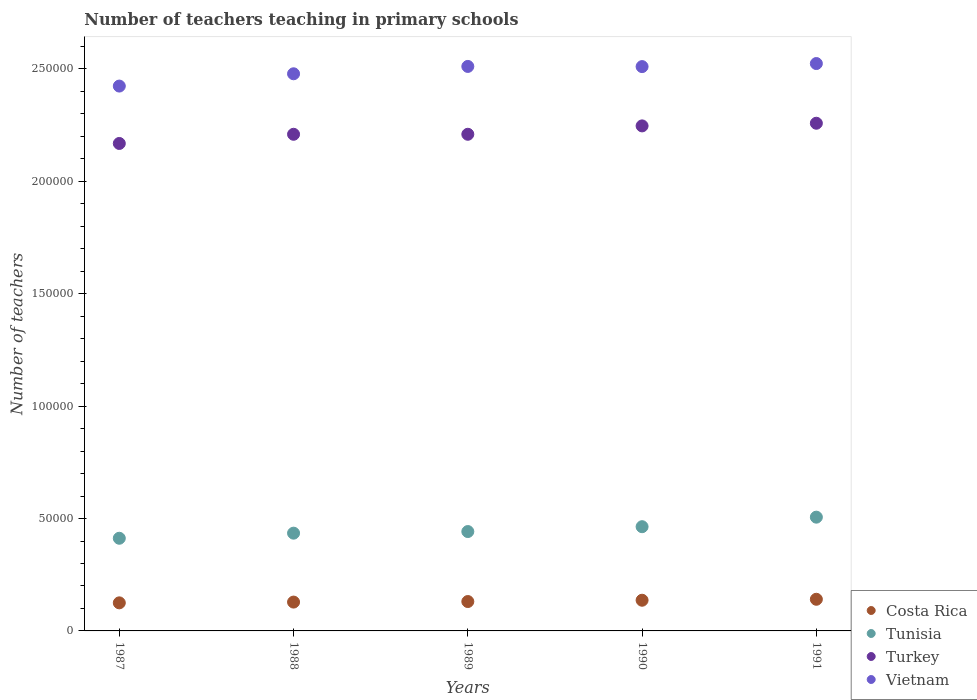How many different coloured dotlines are there?
Offer a very short reply. 4. Is the number of dotlines equal to the number of legend labels?
Your answer should be compact. Yes. What is the number of teachers teaching in primary schools in Costa Rica in 1991?
Provide a succinct answer. 1.41e+04. Across all years, what is the maximum number of teachers teaching in primary schools in Costa Rica?
Offer a terse response. 1.41e+04. Across all years, what is the minimum number of teachers teaching in primary schools in Vietnam?
Provide a succinct answer. 2.42e+05. In which year was the number of teachers teaching in primary schools in Tunisia maximum?
Your answer should be compact. 1991. What is the total number of teachers teaching in primary schools in Tunisia in the graph?
Your response must be concise. 2.26e+05. What is the difference between the number of teachers teaching in primary schools in Tunisia in 1987 and that in 1989?
Your answer should be compact. -2985. What is the difference between the number of teachers teaching in primary schools in Tunisia in 1989 and the number of teachers teaching in primary schools in Costa Rica in 1987?
Keep it short and to the point. 3.17e+04. What is the average number of teachers teaching in primary schools in Tunisia per year?
Offer a terse response. 4.52e+04. In the year 1990, what is the difference between the number of teachers teaching in primary schools in Vietnam and number of teachers teaching in primary schools in Tunisia?
Ensure brevity in your answer.  2.05e+05. What is the ratio of the number of teachers teaching in primary schools in Vietnam in 1990 to that in 1991?
Your answer should be compact. 0.99. Is the number of teachers teaching in primary schools in Turkey in 1987 less than that in 1989?
Keep it short and to the point. Yes. Is the difference between the number of teachers teaching in primary schools in Vietnam in 1988 and 1991 greater than the difference between the number of teachers teaching in primary schools in Tunisia in 1988 and 1991?
Keep it short and to the point. Yes. What is the difference between the highest and the second highest number of teachers teaching in primary schools in Vietnam?
Your response must be concise. 1286. What is the difference between the highest and the lowest number of teachers teaching in primary schools in Vietnam?
Provide a short and direct response. 1.00e+04. In how many years, is the number of teachers teaching in primary schools in Costa Rica greater than the average number of teachers teaching in primary schools in Costa Rica taken over all years?
Give a very brief answer. 2. Does the number of teachers teaching in primary schools in Vietnam monotonically increase over the years?
Provide a succinct answer. No. Is the number of teachers teaching in primary schools in Vietnam strictly greater than the number of teachers teaching in primary schools in Tunisia over the years?
Ensure brevity in your answer.  Yes. Is the number of teachers teaching in primary schools in Costa Rica strictly less than the number of teachers teaching in primary schools in Vietnam over the years?
Your answer should be very brief. Yes. How many years are there in the graph?
Give a very brief answer. 5. What is the difference between two consecutive major ticks on the Y-axis?
Give a very brief answer. 5.00e+04. Are the values on the major ticks of Y-axis written in scientific E-notation?
Keep it short and to the point. No. Does the graph contain any zero values?
Offer a very short reply. No. Does the graph contain grids?
Provide a succinct answer. No. How many legend labels are there?
Your answer should be compact. 4. What is the title of the graph?
Your response must be concise. Number of teachers teaching in primary schools. What is the label or title of the Y-axis?
Keep it short and to the point. Number of teachers. What is the Number of teachers of Costa Rica in 1987?
Offer a terse response. 1.25e+04. What is the Number of teachers of Tunisia in 1987?
Your answer should be compact. 4.12e+04. What is the Number of teachers of Turkey in 1987?
Offer a very short reply. 2.17e+05. What is the Number of teachers of Vietnam in 1987?
Your answer should be very brief. 2.42e+05. What is the Number of teachers in Costa Rica in 1988?
Give a very brief answer. 1.28e+04. What is the Number of teachers in Tunisia in 1988?
Make the answer very short. 4.35e+04. What is the Number of teachers in Turkey in 1988?
Offer a very short reply. 2.21e+05. What is the Number of teachers in Vietnam in 1988?
Ensure brevity in your answer.  2.48e+05. What is the Number of teachers of Costa Rica in 1989?
Provide a succinct answer. 1.31e+04. What is the Number of teachers of Tunisia in 1989?
Your response must be concise. 4.42e+04. What is the Number of teachers in Turkey in 1989?
Offer a very short reply. 2.21e+05. What is the Number of teachers in Vietnam in 1989?
Your answer should be compact. 2.51e+05. What is the Number of teachers of Costa Rica in 1990?
Keep it short and to the point. 1.37e+04. What is the Number of teachers in Tunisia in 1990?
Make the answer very short. 4.64e+04. What is the Number of teachers in Turkey in 1990?
Your response must be concise. 2.25e+05. What is the Number of teachers of Vietnam in 1990?
Your answer should be very brief. 2.51e+05. What is the Number of teachers of Costa Rica in 1991?
Provide a succinct answer. 1.41e+04. What is the Number of teachers in Tunisia in 1991?
Your answer should be compact. 5.06e+04. What is the Number of teachers in Turkey in 1991?
Your answer should be very brief. 2.26e+05. What is the Number of teachers in Vietnam in 1991?
Make the answer very short. 2.52e+05. Across all years, what is the maximum Number of teachers of Costa Rica?
Ensure brevity in your answer.  1.41e+04. Across all years, what is the maximum Number of teachers of Tunisia?
Offer a very short reply. 5.06e+04. Across all years, what is the maximum Number of teachers in Turkey?
Your answer should be very brief. 2.26e+05. Across all years, what is the maximum Number of teachers of Vietnam?
Ensure brevity in your answer.  2.52e+05. Across all years, what is the minimum Number of teachers in Costa Rica?
Offer a terse response. 1.25e+04. Across all years, what is the minimum Number of teachers in Tunisia?
Make the answer very short. 4.12e+04. Across all years, what is the minimum Number of teachers in Turkey?
Your answer should be compact. 2.17e+05. Across all years, what is the minimum Number of teachers of Vietnam?
Ensure brevity in your answer.  2.42e+05. What is the total Number of teachers of Costa Rica in the graph?
Provide a succinct answer. 6.61e+04. What is the total Number of teachers of Tunisia in the graph?
Make the answer very short. 2.26e+05. What is the total Number of teachers of Turkey in the graph?
Your answer should be very brief. 1.11e+06. What is the total Number of teachers of Vietnam in the graph?
Keep it short and to the point. 1.24e+06. What is the difference between the Number of teachers in Costa Rica in 1987 and that in 1988?
Ensure brevity in your answer.  -339. What is the difference between the Number of teachers in Tunisia in 1987 and that in 1988?
Provide a short and direct response. -2267. What is the difference between the Number of teachers of Turkey in 1987 and that in 1988?
Offer a very short reply. -4084. What is the difference between the Number of teachers in Vietnam in 1987 and that in 1988?
Your answer should be compact. -5468. What is the difference between the Number of teachers of Costa Rica in 1987 and that in 1989?
Make the answer very short. -583. What is the difference between the Number of teachers of Tunisia in 1987 and that in 1989?
Make the answer very short. -2985. What is the difference between the Number of teachers in Turkey in 1987 and that in 1989?
Give a very brief answer. -4088. What is the difference between the Number of teachers in Vietnam in 1987 and that in 1989?
Provide a succinct answer. -8739. What is the difference between the Number of teachers of Costa Rica in 1987 and that in 1990?
Your answer should be very brief. -1161. What is the difference between the Number of teachers of Tunisia in 1987 and that in 1990?
Provide a succinct answer. -5143. What is the difference between the Number of teachers in Turkey in 1987 and that in 1990?
Offer a terse response. -7813. What is the difference between the Number of teachers in Vietnam in 1987 and that in 1990?
Offer a very short reply. -8664. What is the difference between the Number of teachers in Costa Rica in 1987 and that in 1991?
Offer a terse response. -1588. What is the difference between the Number of teachers of Tunisia in 1987 and that in 1991?
Offer a very short reply. -9386. What is the difference between the Number of teachers in Turkey in 1987 and that in 1991?
Provide a short and direct response. -8993. What is the difference between the Number of teachers of Vietnam in 1987 and that in 1991?
Give a very brief answer. -1.00e+04. What is the difference between the Number of teachers of Costa Rica in 1988 and that in 1989?
Your response must be concise. -244. What is the difference between the Number of teachers of Tunisia in 1988 and that in 1989?
Your response must be concise. -718. What is the difference between the Number of teachers in Vietnam in 1988 and that in 1989?
Offer a terse response. -3271. What is the difference between the Number of teachers in Costa Rica in 1988 and that in 1990?
Provide a short and direct response. -822. What is the difference between the Number of teachers of Tunisia in 1988 and that in 1990?
Offer a very short reply. -2876. What is the difference between the Number of teachers in Turkey in 1988 and that in 1990?
Your answer should be very brief. -3729. What is the difference between the Number of teachers in Vietnam in 1988 and that in 1990?
Your answer should be very brief. -3196. What is the difference between the Number of teachers in Costa Rica in 1988 and that in 1991?
Provide a succinct answer. -1249. What is the difference between the Number of teachers of Tunisia in 1988 and that in 1991?
Provide a short and direct response. -7119. What is the difference between the Number of teachers of Turkey in 1988 and that in 1991?
Make the answer very short. -4909. What is the difference between the Number of teachers in Vietnam in 1988 and that in 1991?
Provide a succinct answer. -4557. What is the difference between the Number of teachers in Costa Rica in 1989 and that in 1990?
Your answer should be compact. -578. What is the difference between the Number of teachers of Tunisia in 1989 and that in 1990?
Give a very brief answer. -2158. What is the difference between the Number of teachers of Turkey in 1989 and that in 1990?
Give a very brief answer. -3725. What is the difference between the Number of teachers of Vietnam in 1989 and that in 1990?
Make the answer very short. 75. What is the difference between the Number of teachers of Costa Rica in 1989 and that in 1991?
Offer a very short reply. -1005. What is the difference between the Number of teachers in Tunisia in 1989 and that in 1991?
Ensure brevity in your answer.  -6401. What is the difference between the Number of teachers of Turkey in 1989 and that in 1991?
Provide a succinct answer. -4905. What is the difference between the Number of teachers in Vietnam in 1989 and that in 1991?
Give a very brief answer. -1286. What is the difference between the Number of teachers of Costa Rica in 1990 and that in 1991?
Your response must be concise. -427. What is the difference between the Number of teachers of Tunisia in 1990 and that in 1991?
Offer a terse response. -4243. What is the difference between the Number of teachers of Turkey in 1990 and that in 1991?
Your answer should be very brief. -1180. What is the difference between the Number of teachers in Vietnam in 1990 and that in 1991?
Your answer should be compact. -1361. What is the difference between the Number of teachers of Costa Rica in 1987 and the Number of teachers of Tunisia in 1988?
Provide a short and direct response. -3.10e+04. What is the difference between the Number of teachers of Costa Rica in 1987 and the Number of teachers of Turkey in 1988?
Provide a succinct answer. -2.08e+05. What is the difference between the Number of teachers in Costa Rica in 1987 and the Number of teachers in Vietnam in 1988?
Your response must be concise. -2.35e+05. What is the difference between the Number of teachers of Tunisia in 1987 and the Number of teachers of Turkey in 1988?
Provide a succinct answer. -1.80e+05. What is the difference between the Number of teachers in Tunisia in 1987 and the Number of teachers in Vietnam in 1988?
Provide a succinct answer. -2.07e+05. What is the difference between the Number of teachers of Turkey in 1987 and the Number of teachers of Vietnam in 1988?
Offer a terse response. -3.10e+04. What is the difference between the Number of teachers of Costa Rica in 1987 and the Number of teachers of Tunisia in 1989?
Give a very brief answer. -3.17e+04. What is the difference between the Number of teachers in Costa Rica in 1987 and the Number of teachers in Turkey in 1989?
Offer a very short reply. -2.08e+05. What is the difference between the Number of teachers in Costa Rica in 1987 and the Number of teachers in Vietnam in 1989?
Keep it short and to the point. -2.39e+05. What is the difference between the Number of teachers in Tunisia in 1987 and the Number of teachers in Turkey in 1989?
Give a very brief answer. -1.80e+05. What is the difference between the Number of teachers in Tunisia in 1987 and the Number of teachers in Vietnam in 1989?
Provide a short and direct response. -2.10e+05. What is the difference between the Number of teachers in Turkey in 1987 and the Number of teachers in Vietnam in 1989?
Offer a very short reply. -3.43e+04. What is the difference between the Number of teachers in Costa Rica in 1987 and the Number of teachers in Tunisia in 1990?
Keep it short and to the point. -3.39e+04. What is the difference between the Number of teachers in Costa Rica in 1987 and the Number of teachers in Turkey in 1990?
Offer a terse response. -2.12e+05. What is the difference between the Number of teachers of Costa Rica in 1987 and the Number of teachers of Vietnam in 1990?
Ensure brevity in your answer.  -2.39e+05. What is the difference between the Number of teachers of Tunisia in 1987 and the Number of teachers of Turkey in 1990?
Your answer should be compact. -1.83e+05. What is the difference between the Number of teachers of Tunisia in 1987 and the Number of teachers of Vietnam in 1990?
Provide a short and direct response. -2.10e+05. What is the difference between the Number of teachers of Turkey in 1987 and the Number of teachers of Vietnam in 1990?
Ensure brevity in your answer.  -3.42e+04. What is the difference between the Number of teachers in Costa Rica in 1987 and the Number of teachers in Tunisia in 1991?
Offer a terse response. -3.81e+04. What is the difference between the Number of teachers of Costa Rica in 1987 and the Number of teachers of Turkey in 1991?
Offer a very short reply. -2.13e+05. What is the difference between the Number of teachers in Costa Rica in 1987 and the Number of teachers in Vietnam in 1991?
Ensure brevity in your answer.  -2.40e+05. What is the difference between the Number of teachers of Tunisia in 1987 and the Number of teachers of Turkey in 1991?
Provide a succinct answer. -1.85e+05. What is the difference between the Number of teachers of Tunisia in 1987 and the Number of teachers of Vietnam in 1991?
Offer a terse response. -2.11e+05. What is the difference between the Number of teachers in Turkey in 1987 and the Number of teachers in Vietnam in 1991?
Provide a succinct answer. -3.56e+04. What is the difference between the Number of teachers in Costa Rica in 1988 and the Number of teachers in Tunisia in 1989?
Your response must be concise. -3.14e+04. What is the difference between the Number of teachers of Costa Rica in 1988 and the Number of teachers of Turkey in 1989?
Ensure brevity in your answer.  -2.08e+05. What is the difference between the Number of teachers of Costa Rica in 1988 and the Number of teachers of Vietnam in 1989?
Your answer should be compact. -2.38e+05. What is the difference between the Number of teachers of Tunisia in 1988 and the Number of teachers of Turkey in 1989?
Offer a terse response. -1.77e+05. What is the difference between the Number of teachers in Tunisia in 1988 and the Number of teachers in Vietnam in 1989?
Your answer should be very brief. -2.08e+05. What is the difference between the Number of teachers of Turkey in 1988 and the Number of teachers of Vietnam in 1989?
Provide a short and direct response. -3.02e+04. What is the difference between the Number of teachers of Costa Rica in 1988 and the Number of teachers of Tunisia in 1990?
Offer a very short reply. -3.35e+04. What is the difference between the Number of teachers in Costa Rica in 1988 and the Number of teachers in Turkey in 1990?
Provide a succinct answer. -2.12e+05. What is the difference between the Number of teachers of Costa Rica in 1988 and the Number of teachers of Vietnam in 1990?
Ensure brevity in your answer.  -2.38e+05. What is the difference between the Number of teachers of Tunisia in 1988 and the Number of teachers of Turkey in 1990?
Your answer should be compact. -1.81e+05. What is the difference between the Number of teachers of Tunisia in 1988 and the Number of teachers of Vietnam in 1990?
Provide a short and direct response. -2.08e+05. What is the difference between the Number of teachers in Turkey in 1988 and the Number of teachers in Vietnam in 1990?
Give a very brief answer. -3.01e+04. What is the difference between the Number of teachers of Costa Rica in 1988 and the Number of teachers of Tunisia in 1991?
Provide a succinct answer. -3.78e+04. What is the difference between the Number of teachers of Costa Rica in 1988 and the Number of teachers of Turkey in 1991?
Give a very brief answer. -2.13e+05. What is the difference between the Number of teachers in Costa Rica in 1988 and the Number of teachers in Vietnam in 1991?
Offer a terse response. -2.40e+05. What is the difference between the Number of teachers of Tunisia in 1988 and the Number of teachers of Turkey in 1991?
Provide a succinct answer. -1.82e+05. What is the difference between the Number of teachers of Tunisia in 1988 and the Number of teachers of Vietnam in 1991?
Offer a very short reply. -2.09e+05. What is the difference between the Number of teachers in Turkey in 1988 and the Number of teachers in Vietnam in 1991?
Make the answer very short. -3.15e+04. What is the difference between the Number of teachers of Costa Rica in 1989 and the Number of teachers of Tunisia in 1990?
Keep it short and to the point. -3.33e+04. What is the difference between the Number of teachers in Costa Rica in 1989 and the Number of teachers in Turkey in 1990?
Provide a succinct answer. -2.12e+05. What is the difference between the Number of teachers of Costa Rica in 1989 and the Number of teachers of Vietnam in 1990?
Offer a terse response. -2.38e+05. What is the difference between the Number of teachers in Tunisia in 1989 and the Number of teachers in Turkey in 1990?
Your answer should be very brief. -1.80e+05. What is the difference between the Number of teachers in Tunisia in 1989 and the Number of teachers in Vietnam in 1990?
Offer a terse response. -2.07e+05. What is the difference between the Number of teachers in Turkey in 1989 and the Number of teachers in Vietnam in 1990?
Keep it short and to the point. -3.01e+04. What is the difference between the Number of teachers of Costa Rica in 1989 and the Number of teachers of Tunisia in 1991?
Give a very brief answer. -3.75e+04. What is the difference between the Number of teachers in Costa Rica in 1989 and the Number of teachers in Turkey in 1991?
Keep it short and to the point. -2.13e+05. What is the difference between the Number of teachers of Costa Rica in 1989 and the Number of teachers of Vietnam in 1991?
Offer a very short reply. -2.39e+05. What is the difference between the Number of teachers in Tunisia in 1989 and the Number of teachers in Turkey in 1991?
Your response must be concise. -1.82e+05. What is the difference between the Number of teachers of Tunisia in 1989 and the Number of teachers of Vietnam in 1991?
Your answer should be very brief. -2.08e+05. What is the difference between the Number of teachers of Turkey in 1989 and the Number of teachers of Vietnam in 1991?
Your answer should be very brief. -3.15e+04. What is the difference between the Number of teachers of Costa Rica in 1990 and the Number of teachers of Tunisia in 1991?
Your response must be concise. -3.70e+04. What is the difference between the Number of teachers of Costa Rica in 1990 and the Number of teachers of Turkey in 1991?
Provide a succinct answer. -2.12e+05. What is the difference between the Number of teachers of Costa Rica in 1990 and the Number of teachers of Vietnam in 1991?
Offer a very short reply. -2.39e+05. What is the difference between the Number of teachers in Tunisia in 1990 and the Number of teachers in Turkey in 1991?
Give a very brief answer. -1.79e+05. What is the difference between the Number of teachers of Tunisia in 1990 and the Number of teachers of Vietnam in 1991?
Offer a very short reply. -2.06e+05. What is the difference between the Number of teachers of Turkey in 1990 and the Number of teachers of Vietnam in 1991?
Keep it short and to the point. -2.77e+04. What is the average Number of teachers in Costa Rica per year?
Ensure brevity in your answer.  1.32e+04. What is the average Number of teachers of Tunisia per year?
Offer a terse response. 4.52e+04. What is the average Number of teachers of Turkey per year?
Offer a very short reply. 2.22e+05. What is the average Number of teachers of Vietnam per year?
Offer a terse response. 2.49e+05. In the year 1987, what is the difference between the Number of teachers of Costa Rica and Number of teachers of Tunisia?
Ensure brevity in your answer.  -2.87e+04. In the year 1987, what is the difference between the Number of teachers in Costa Rica and Number of teachers in Turkey?
Your response must be concise. -2.04e+05. In the year 1987, what is the difference between the Number of teachers of Costa Rica and Number of teachers of Vietnam?
Your response must be concise. -2.30e+05. In the year 1987, what is the difference between the Number of teachers of Tunisia and Number of teachers of Turkey?
Your answer should be compact. -1.76e+05. In the year 1987, what is the difference between the Number of teachers of Tunisia and Number of teachers of Vietnam?
Your answer should be very brief. -2.01e+05. In the year 1987, what is the difference between the Number of teachers of Turkey and Number of teachers of Vietnam?
Ensure brevity in your answer.  -2.55e+04. In the year 1988, what is the difference between the Number of teachers in Costa Rica and Number of teachers in Tunisia?
Your answer should be compact. -3.07e+04. In the year 1988, what is the difference between the Number of teachers in Costa Rica and Number of teachers in Turkey?
Offer a very short reply. -2.08e+05. In the year 1988, what is the difference between the Number of teachers of Costa Rica and Number of teachers of Vietnam?
Offer a very short reply. -2.35e+05. In the year 1988, what is the difference between the Number of teachers of Tunisia and Number of teachers of Turkey?
Offer a very short reply. -1.77e+05. In the year 1988, what is the difference between the Number of teachers of Tunisia and Number of teachers of Vietnam?
Provide a short and direct response. -2.04e+05. In the year 1988, what is the difference between the Number of teachers in Turkey and Number of teachers in Vietnam?
Provide a short and direct response. -2.69e+04. In the year 1989, what is the difference between the Number of teachers in Costa Rica and Number of teachers in Tunisia?
Give a very brief answer. -3.11e+04. In the year 1989, what is the difference between the Number of teachers of Costa Rica and Number of teachers of Turkey?
Provide a short and direct response. -2.08e+05. In the year 1989, what is the difference between the Number of teachers of Costa Rica and Number of teachers of Vietnam?
Give a very brief answer. -2.38e+05. In the year 1989, what is the difference between the Number of teachers of Tunisia and Number of teachers of Turkey?
Your answer should be very brief. -1.77e+05. In the year 1989, what is the difference between the Number of teachers in Tunisia and Number of teachers in Vietnam?
Your answer should be very brief. -2.07e+05. In the year 1989, what is the difference between the Number of teachers in Turkey and Number of teachers in Vietnam?
Offer a very short reply. -3.02e+04. In the year 1990, what is the difference between the Number of teachers of Costa Rica and Number of teachers of Tunisia?
Offer a very short reply. -3.27e+04. In the year 1990, what is the difference between the Number of teachers in Costa Rica and Number of teachers in Turkey?
Keep it short and to the point. -2.11e+05. In the year 1990, what is the difference between the Number of teachers of Costa Rica and Number of teachers of Vietnam?
Your response must be concise. -2.37e+05. In the year 1990, what is the difference between the Number of teachers in Tunisia and Number of teachers in Turkey?
Offer a terse response. -1.78e+05. In the year 1990, what is the difference between the Number of teachers in Tunisia and Number of teachers in Vietnam?
Make the answer very short. -2.05e+05. In the year 1990, what is the difference between the Number of teachers in Turkey and Number of teachers in Vietnam?
Your answer should be very brief. -2.64e+04. In the year 1991, what is the difference between the Number of teachers in Costa Rica and Number of teachers in Tunisia?
Your answer should be very brief. -3.65e+04. In the year 1991, what is the difference between the Number of teachers of Costa Rica and Number of teachers of Turkey?
Provide a succinct answer. -2.12e+05. In the year 1991, what is the difference between the Number of teachers in Costa Rica and Number of teachers in Vietnam?
Ensure brevity in your answer.  -2.38e+05. In the year 1991, what is the difference between the Number of teachers of Tunisia and Number of teachers of Turkey?
Provide a short and direct response. -1.75e+05. In the year 1991, what is the difference between the Number of teachers of Tunisia and Number of teachers of Vietnam?
Your response must be concise. -2.02e+05. In the year 1991, what is the difference between the Number of teachers in Turkey and Number of teachers in Vietnam?
Offer a terse response. -2.66e+04. What is the ratio of the Number of teachers of Costa Rica in 1987 to that in 1988?
Keep it short and to the point. 0.97. What is the ratio of the Number of teachers of Tunisia in 1987 to that in 1988?
Offer a very short reply. 0.95. What is the ratio of the Number of teachers in Turkey in 1987 to that in 1988?
Offer a terse response. 0.98. What is the ratio of the Number of teachers of Vietnam in 1987 to that in 1988?
Offer a very short reply. 0.98. What is the ratio of the Number of teachers of Costa Rica in 1987 to that in 1989?
Provide a succinct answer. 0.96. What is the ratio of the Number of teachers of Tunisia in 1987 to that in 1989?
Your response must be concise. 0.93. What is the ratio of the Number of teachers in Turkey in 1987 to that in 1989?
Provide a short and direct response. 0.98. What is the ratio of the Number of teachers in Vietnam in 1987 to that in 1989?
Your response must be concise. 0.97. What is the ratio of the Number of teachers in Costa Rica in 1987 to that in 1990?
Offer a very short reply. 0.92. What is the ratio of the Number of teachers of Tunisia in 1987 to that in 1990?
Keep it short and to the point. 0.89. What is the ratio of the Number of teachers in Turkey in 1987 to that in 1990?
Ensure brevity in your answer.  0.97. What is the ratio of the Number of teachers in Vietnam in 1987 to that in 1990?
Your answer should be compact. 0.97. What is the ratio of the Number of teachers in Costa Rica in 1987 to that in 1991?
Your answer should be very brief. 0.89. What is the ratio of the Number of teachers of Tunisia in 1987 to that in 1991?
Offer a very short reply. 0.81. What is the ratio of the Number of teachers in Turkey in 1987 to that in 1991?
Provide a short and direct response. 0.96. What is the ratio of the Number of teachers of Vietnam in 1987 to that in 1991?
Offer a terse response. 0.96. What is the ratio of the Number of teachers in Costa Rica in 1988 to that in 1989?
Your answer should be very brief. 0.98. What is the ratio of the Number of teachers of Tunisia in 1988 to that in 1989?
Keep it short and to the point. 0.98. What is the ratio of the Number of teachers of Turkey in 1988 to that in 1989?
Your response must be concise. 1. What is the ratio of the Number of teachers of Vietnam in 1988 to that in 1989?
Offer a terse response. 0.99. What is the ratio of the Number of teachers in Costa Rica in 1988 to that in 1990?
Offer a very short reply. 0.94. What is the ratio of the Number of teachers of Tunisia in 1988 to that in 1990?
Offer a terse response. 0.94. What is the ratio of the Number of teachers in Turkey in 1988 to that in 1990?
Your answer should be very brief. 0.98. What is the ratio of the Number of teachers of Vietnam in 1988 to that in 1990?
Your response must be concise. 0.99. What is the ratio of the Number of teachers of Costa Rica in 1988 to that in 1991?
Your answer should be compact. 0.91. What is the ratio of the Number of teachers of Tunisia in 1988 to that in 1991?
Your response must be concise. 0.86. What is the ratio of the Number of teachers of Turkey in 1988 to that in 1991?
Offer a terse response. 0.98. What is the ratio of the Number of teachers of Vietnam in 1988 to that in 1991?
Your response must be concise. 0.98. What is the ratio of the Number of teachers of Costa Rica in 1989 to that in 1990?
Offer a terse response. 0.96. What is the ratio of the Number of teachers of Tunisia in 1989 to that in 1990?
Ensure brevity in your answer.  0.95. What is the ratio of the Number of teachers in Turkey in 1989 to that in 1990?
Keep it short and to the point. 0.98. What is the ratio of the Number of teachers of Costa Rica in 1989 to that in 1991?
Ensure brevity in your answer.  0.93. What is the ratio of the Number of teachers of Tunisia in 1989 to that in 1991?
Provide a succinct answer. 0.87. What is the ratio of the Number of teachers in Turkey in 1989 to that in 1991?
Ensure brevity in your answer.  0.98. What is the ratio of the Number of teachers in Costa Rica in 1990 to that in 1991?
Your answer should be compact. 0.97. What is the ratio of the Number of teachers in Tunisia in 1990 to that in 1991?
Offer a very short reply. 0.92. What is the difference between the highest and the second highest Number of teachers in Costa Rica?
Your answer should be compact. 427. What is the difference between the highest and the second highest Number of teachers in Tunisia?
Make the answer very short. 4243. What is the difference between the highest and the second highest Number of teachers in Turkey?
Offer a very short reply. 1180. What is the difference between the highest and the second highest Number of teachers in Vietnam?
Your answer should be compact. 1286. What is the difference between the highest and the lowest Number of teachers in Costa Rica?
Give a very brief answer. 1588. What is the difference between the highest and the lowest Number of teachers of Tunisia?
Provide a short and direct response. 9386. What is the difference between the highest and the lowest Number of teachers in Turkey?
Offer a very short reply. 8993. What is the difference between the highest and the lowest Number of teachers of Vietnam?
Offer a very short reply. 1.00e+04. 